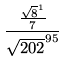Convert formula to latex. <formula><loc_0><loc_0><loc_500><loc_500>\frac { \frac { \sqrt { 8 } ^ { 1 } } { 7 } } { \sqrt { 2 0 2 } ^ { 9 5 } }</formula> 